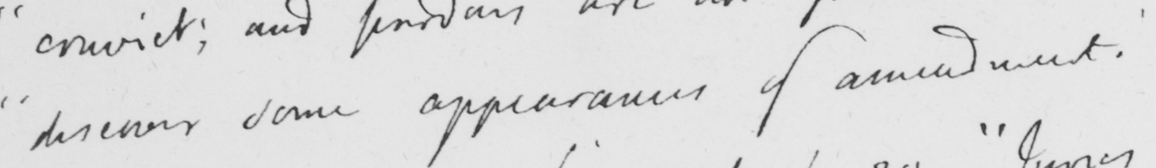What does this handwritten line say? " discover some appearances of amendment . 